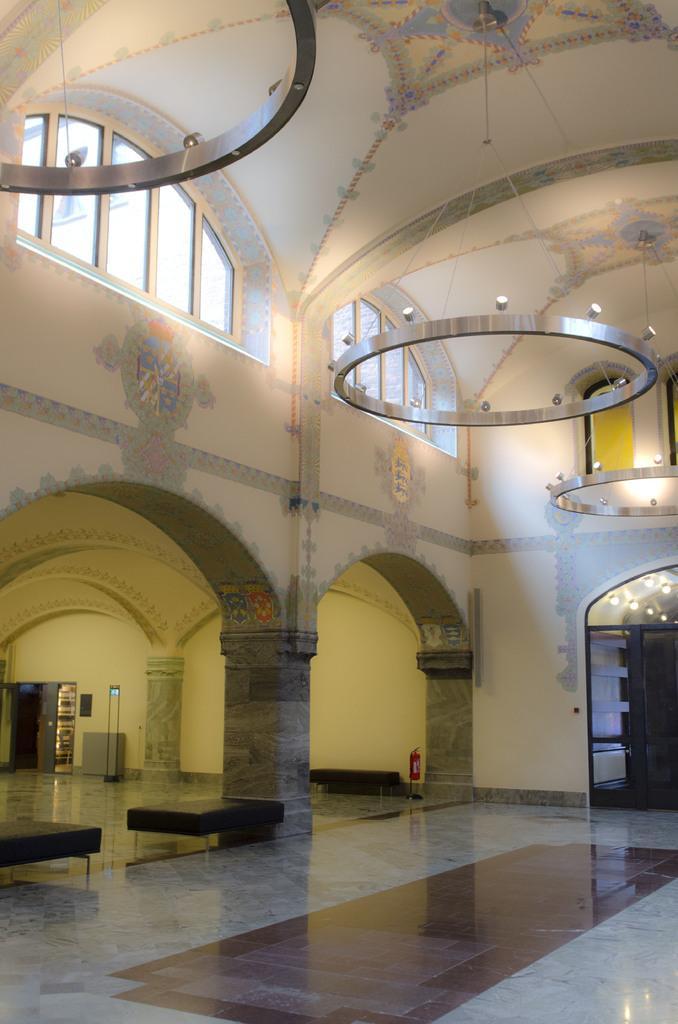Describe this image in one or two sentences. In this picture we can see an inside view of a building, we can see a pillar at the bottom, there are some lights in the middle, in the background there is a wall, we can also see a fire extinguisher and couches at the bottom. 